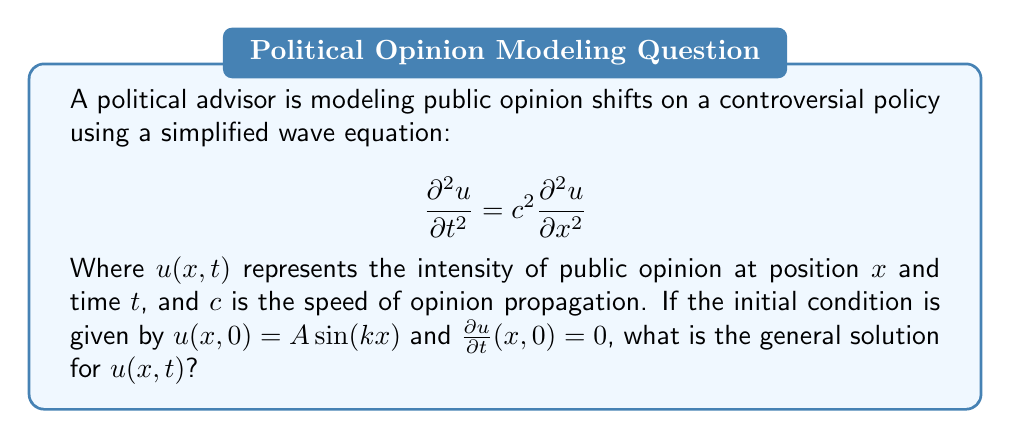Help me with this question. To solve this wave equation with the given initial conditions, we follow these steps:

1) The general solution for the wave equation is of the form:
   $$u(x,t) = f(x-ct) + g(x+ct)$$
   where $f$ and $g$ are arbitrary functions.

2) Given the initial condition $u(x,0) = A\sin(kx)$, we can write:
   $$f(x) + g(x) = A\sin(kx)$$

3) The second initial condition $\frac{\partial u}{\partial t}(x,0) = 0$ implies:
   $$-cf'(x) + cg'(x) = 0$$
   or $f'(x) = g'(x)$

4) Integrating this, we get $f(x) = g(x) + C$, where $C$ is a constant.

5) Substituting this into the equation from step 2:
   $$2f(x) + C = A\sin(kx)$$
   $$f(x) = \frac{A}{2}\sin(kx) - \frac{C}{2}$$
   $$g(x) = \frac{A}{2}\sin(kx) + \frac{C}{2}$$

6) The constant $C$ can be absorbed into the sine function, so we can simplify to:
   $$f(x) = g(x) = \frac{A}{2}\sin(kx)$$

7) Substituting these into the general solution:
   $$u(x,t) = \frac{A}{2}\sin(k(x-ct)) + \frac{A}{2}\sin(k(x+ct))$$

8) Using the trigonometric identity for the sum of sines:
   $$u(x,t) = A\sin(kx)\cos(kct)$$

This is the general solution that satisfies the wave equation and the given initial conditions.
Answer: $u(x,t) = A\sin(kx)\cos(kct)$ 